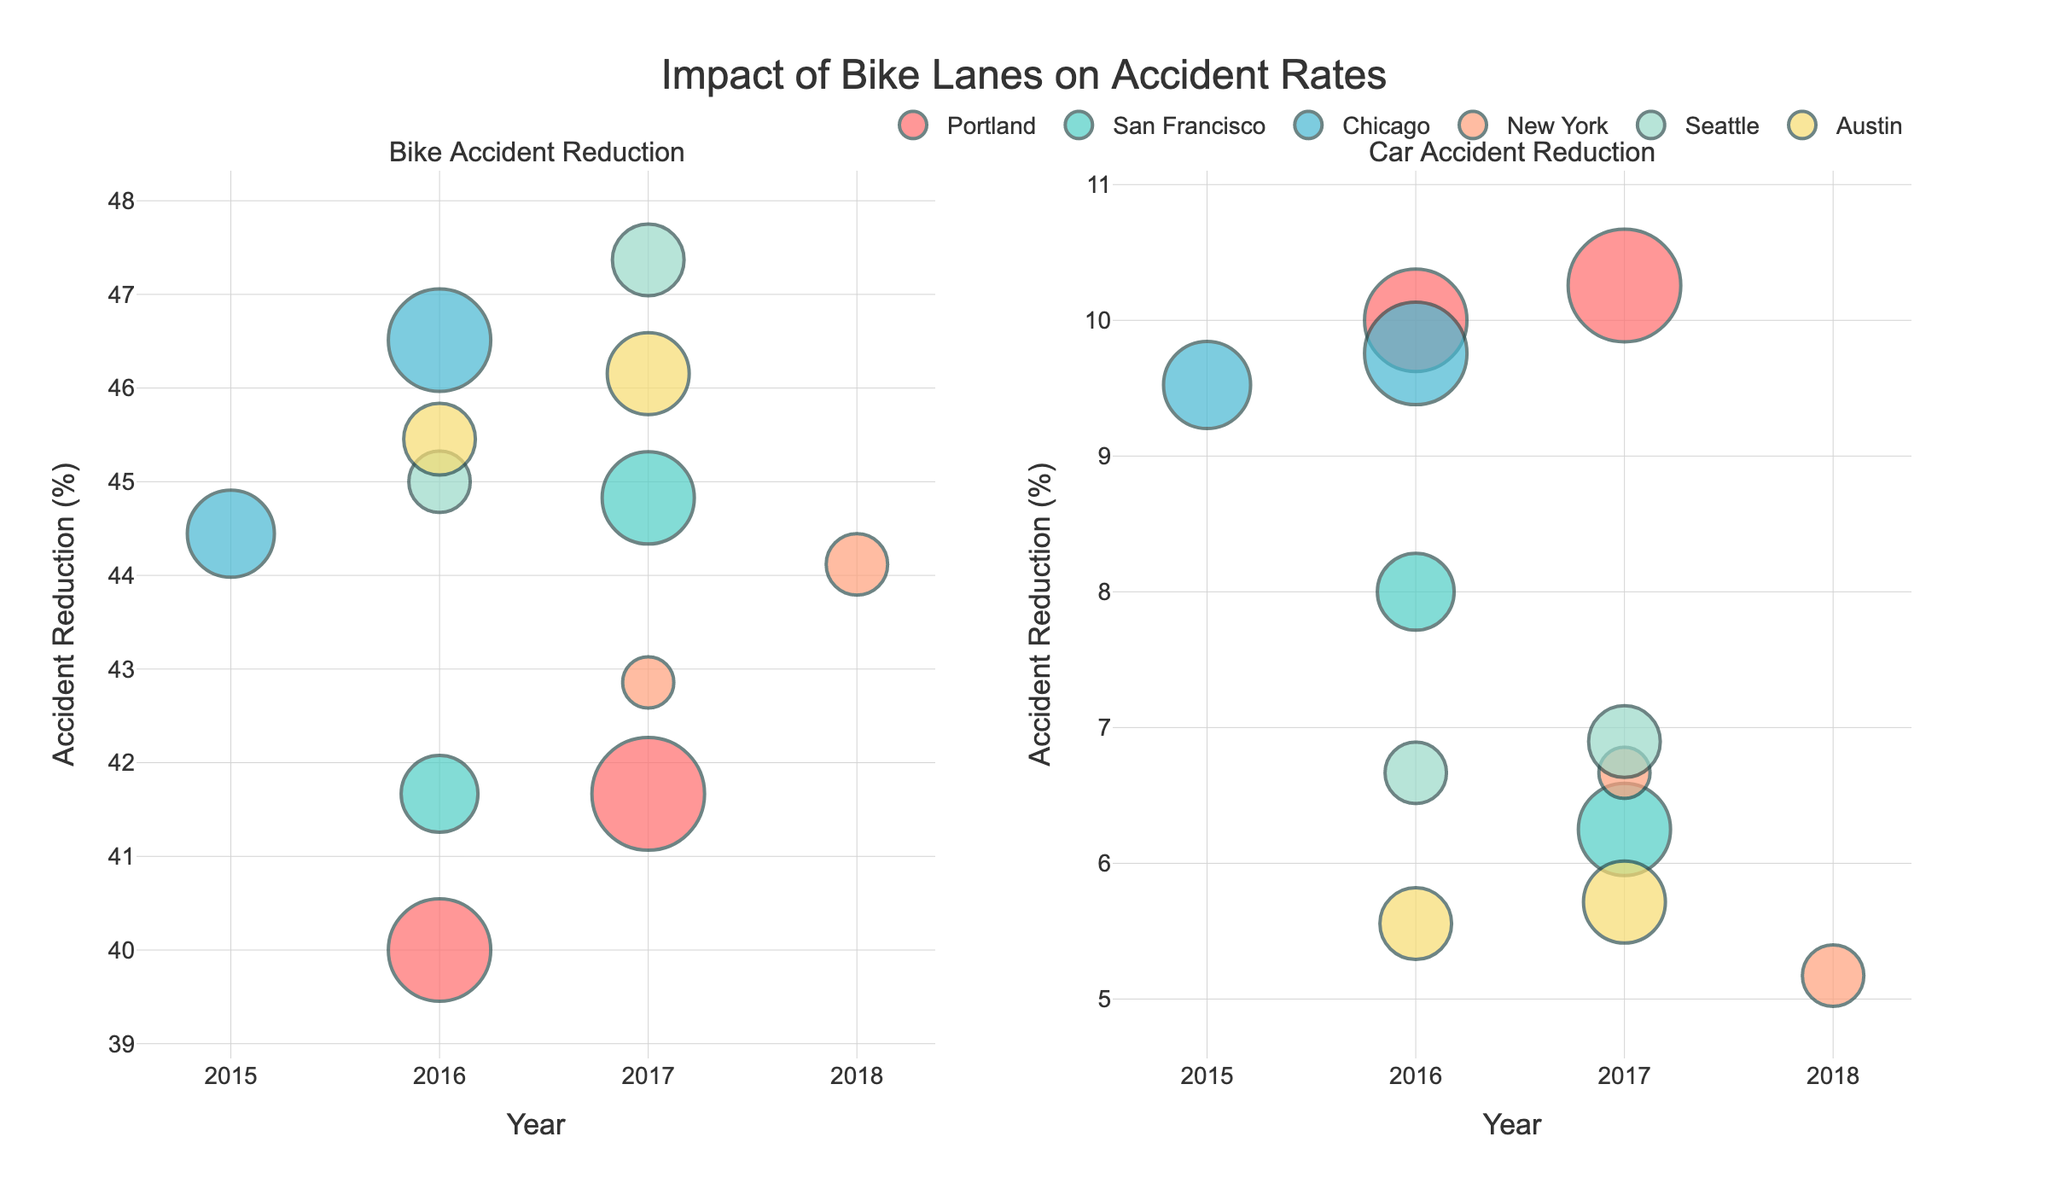What is the title of the figure? The title of the figure is displayed at the top center of the plot. It reads "Impact of Bike Lanes on Accident Rates."
Answer: Impact of Bike Lanes on Accident Rates Which subplot shows the reduction in bike accidents? The figure is divided into two subplots. The left subplot shows "Bike Accident Reduction," indicating it focuses on bike accidents.
Answer: The left subplot Which city shows the highest reduction in bike accident rates in 2017? In the left subplot, hover over or locate the markers for the year 2017. The city with the highest reduction in bike accident rates, according to the size and position of the bubble, appears to be New York.
Answer: New York Compare the accident reduction rates for cars and bikes in San Francisco for the years given. By looking at the positions of San Francisco’s bubbles in both subplots (left for bikes, right for cars) across the years, we observe that the reduction in bike accidents is generally higher than that for cars.
Answer: Bike accident reduction is generally higher What is the size of the bubble representing Chicago’s bike lanes in 2015? Look at the left subplot and find the marker for Chicago in 2015. The size of the bubble is proportional to the number of bike lanes times three. Chicago had 17 bike lanes, so 17 * 3 = 51.
Answer: 51 Which city experienced an increase in the number of bike lanes from 2016 to 2017? Compare the bubble sizes for each city in 2016 and 2017 in the left subplot. Portland, San Francisco, New York, Seattle, and Austin show an increase in the bubble size, indicating more bike lanes in 2017.
Answer: Portland, San Francisco, New York, Seattle, Austin How did the reduction in car accident rates in Seattle compare to Austin for the year 2017? In the right subplot (Car Accident Reduction) for 2017, compare the positions of bubbles for Seattle and Austin. Seattle has a slightly higher reduction rate than Austin, as evident from its higher position.
Answer: Seattle has a higher reduction rate What is the range of the reduction percentages for bike accidents in the plot? In the left subplot (Bike Accident Reduction), find the vertical range of bubble positions. The lowest point appears around 40%, and the highest is just under 60%.
Answer: 40% to 60% Explain the relationship between the number of bike lanes and accident reduction rates observed in the figure. Generally, cities with more bike lanes show higher reduction rates in bike accidents, as indicated by larger bubbles positioned higher on the vertical axis in the left subplot.
Answer: More bike lanes tend to correspond to higher reduction rates in bike accidents Which city had the smallest reduction in bike accident rates in 2016? In the left subplot (Bike Accident Reduction), find the year 2016. The lowest positioned bubble belongs to Austin, indicating the smallest reduction in bike accident rates.
Answer: Austin 